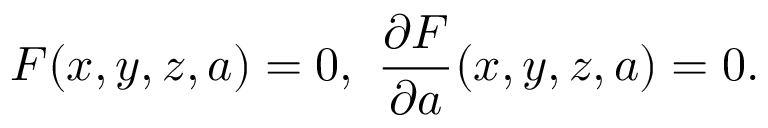Convert formula to latex. <formula><loc_0><loc_0><loc_500><loc_500>F ( x , y , z , a ) = 0 , \, { \frac { \partial F } { \partial a } } ( x , y , z , a ) = 0 .</formula> 